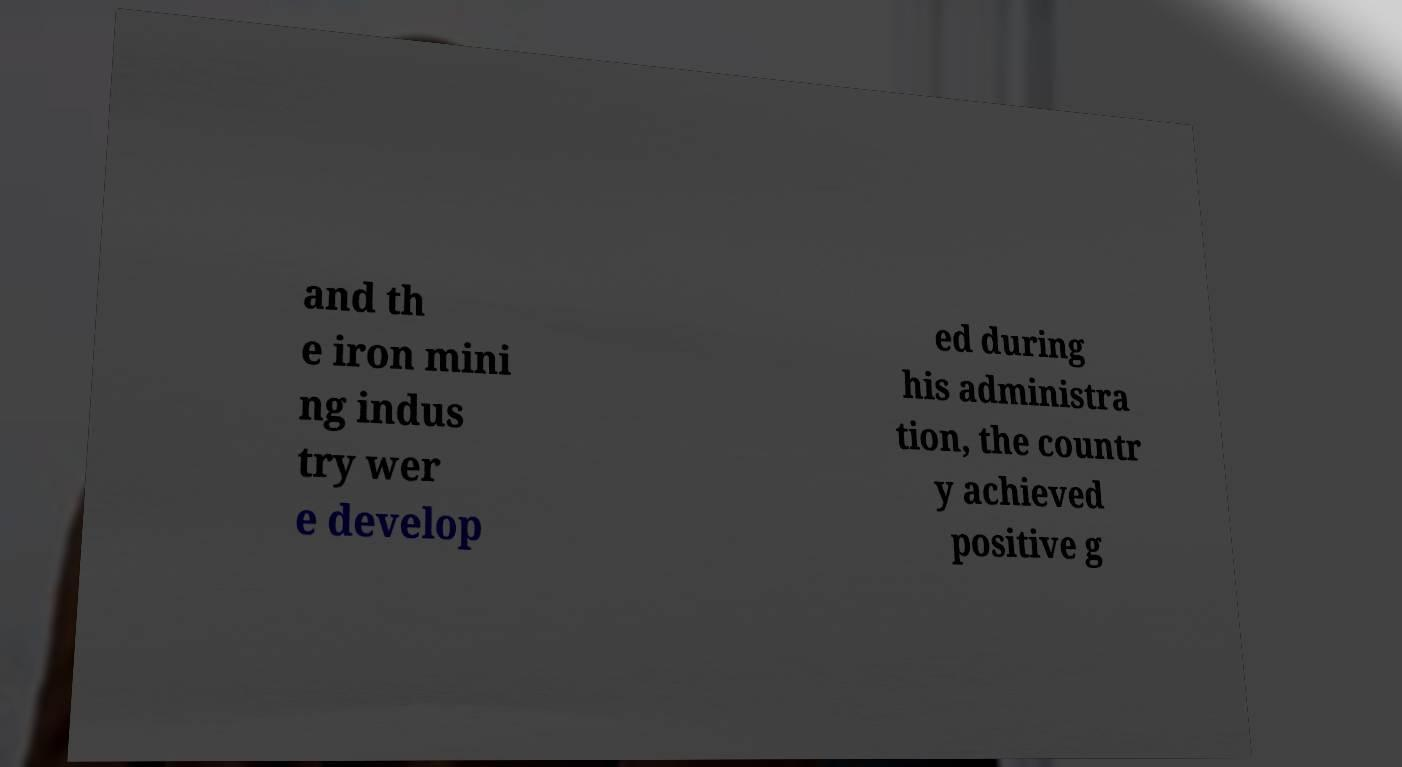Can you read and provide the text displayed in the image?This photo seems to have some interesting text. Can you extract and type it out for me? and th e iron mini ng indus try wer e develop ed during his administra tion, the countr y achieved positive g 